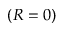Convert formula to latex. <formula><loc_0><loc_0><loc_500><loc_500>( R = 0 )</formula> 